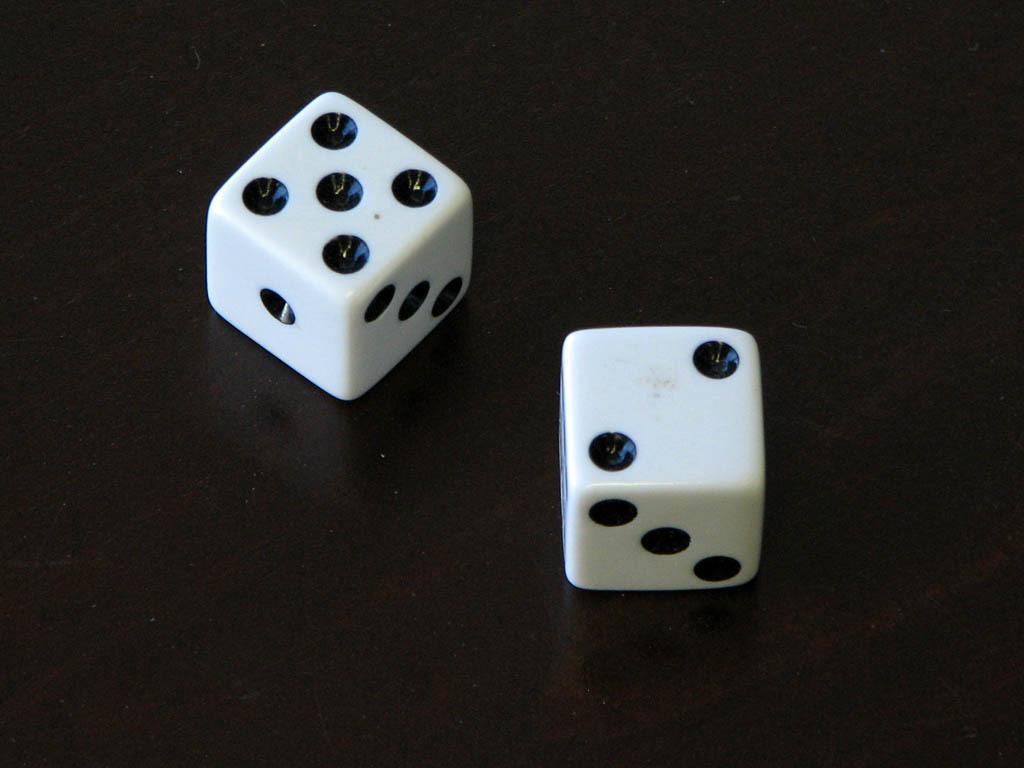How would you summarize this image in a sentence or two? In this image I can see two dice in white and black color and I can see the black color background. 